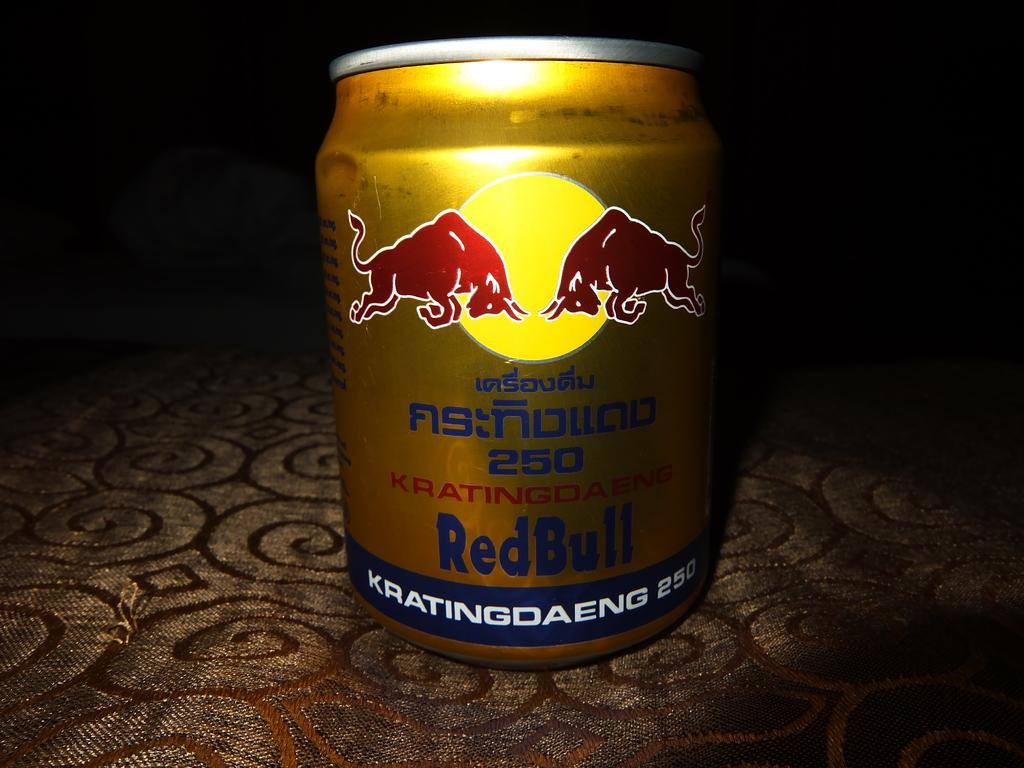<image>
Give a short and clear explanation of the subsequent image. A can of redbull with the words KRATINGDAENG 250 on the bottom. 